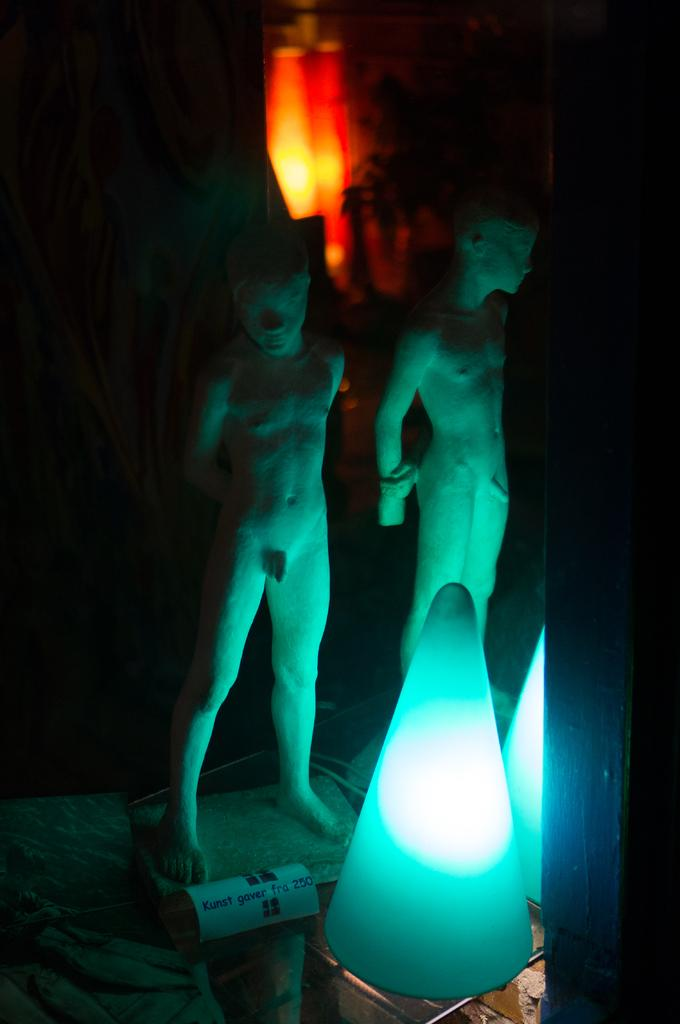What are the main subjects in the center of the image? There are two statues in the center of the image. What is located behind the statues? The statues are in front of lamps. What can be seen in the background of the image? There appears to be fire in the background of the image. Can you tell me how many snakes are wrapped around the statues in the image? There are no snakes present in the image; the statues are not depicted with any snakes. What type of office furniture can be seen in the image? There is no office furniture present in the image; it features statues, lamps, and fire. 